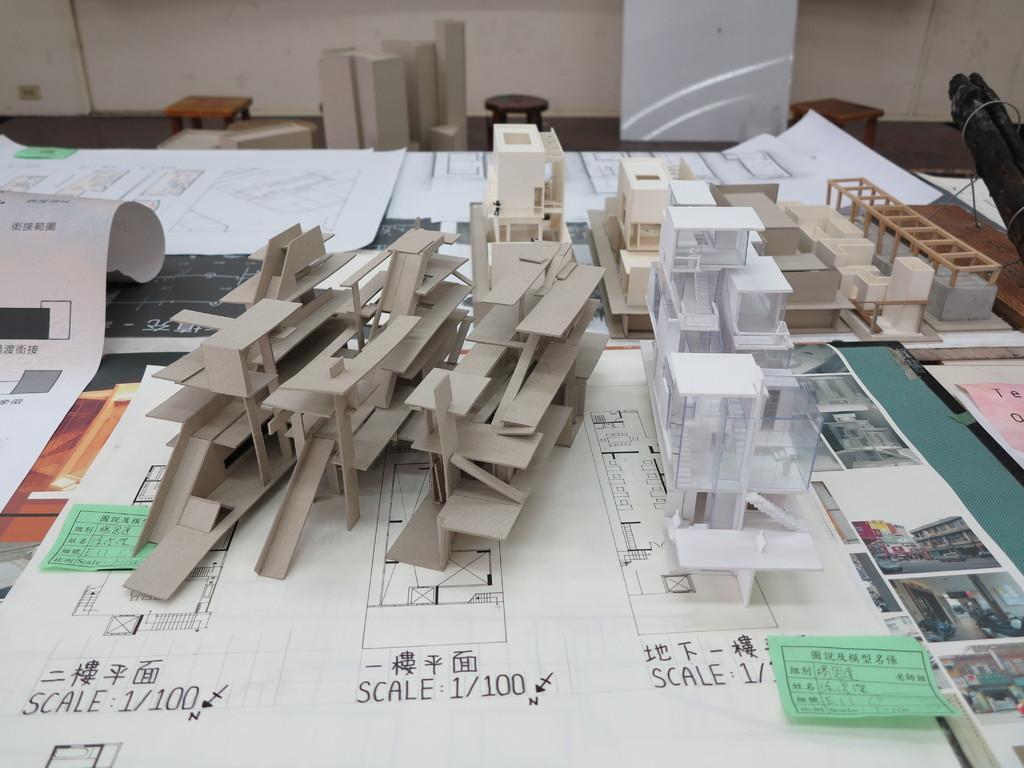Describe this image in one or two sentences. In this image we can see three stools, one wall, so many paper charts on the table and some objects are on the surface. Some objects are on the table. 